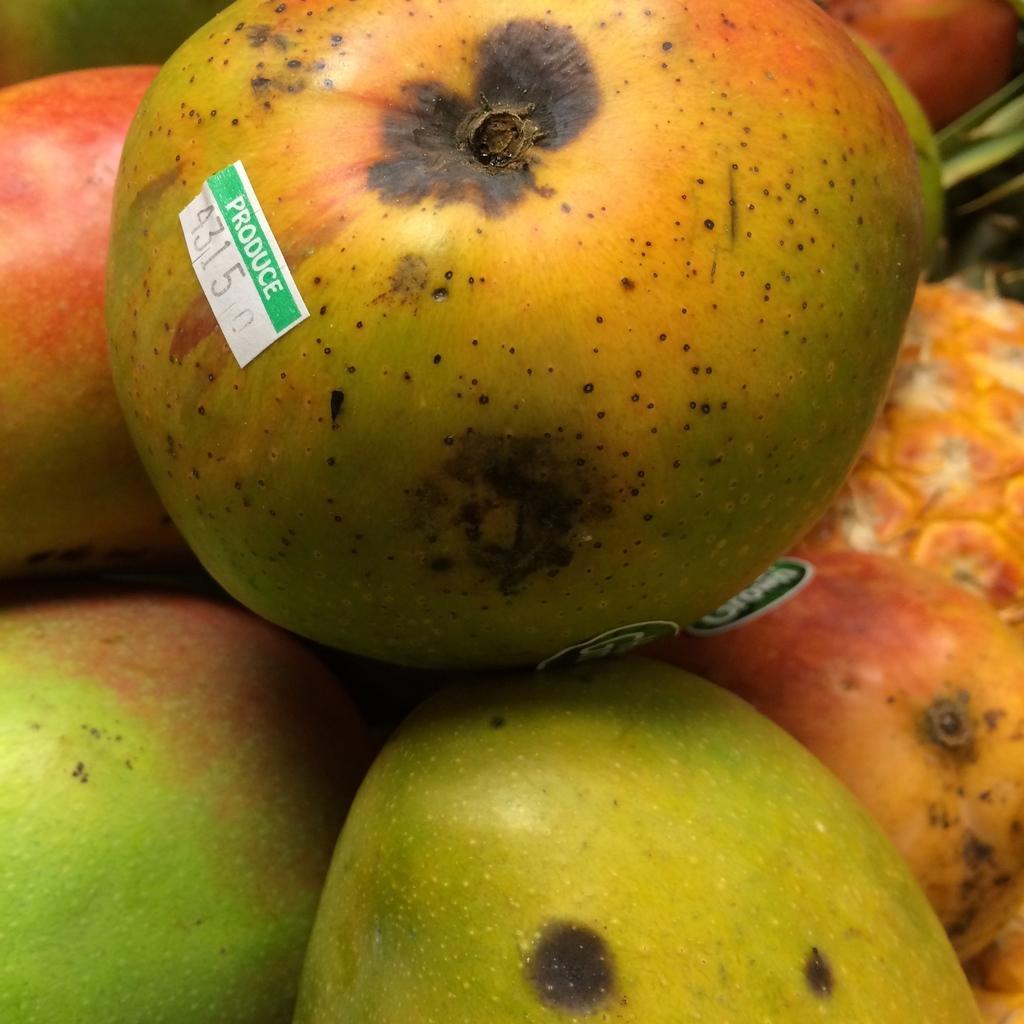Can you describe this image briefly? In this picture I can see there are few apples and there is a label on the fruit. 